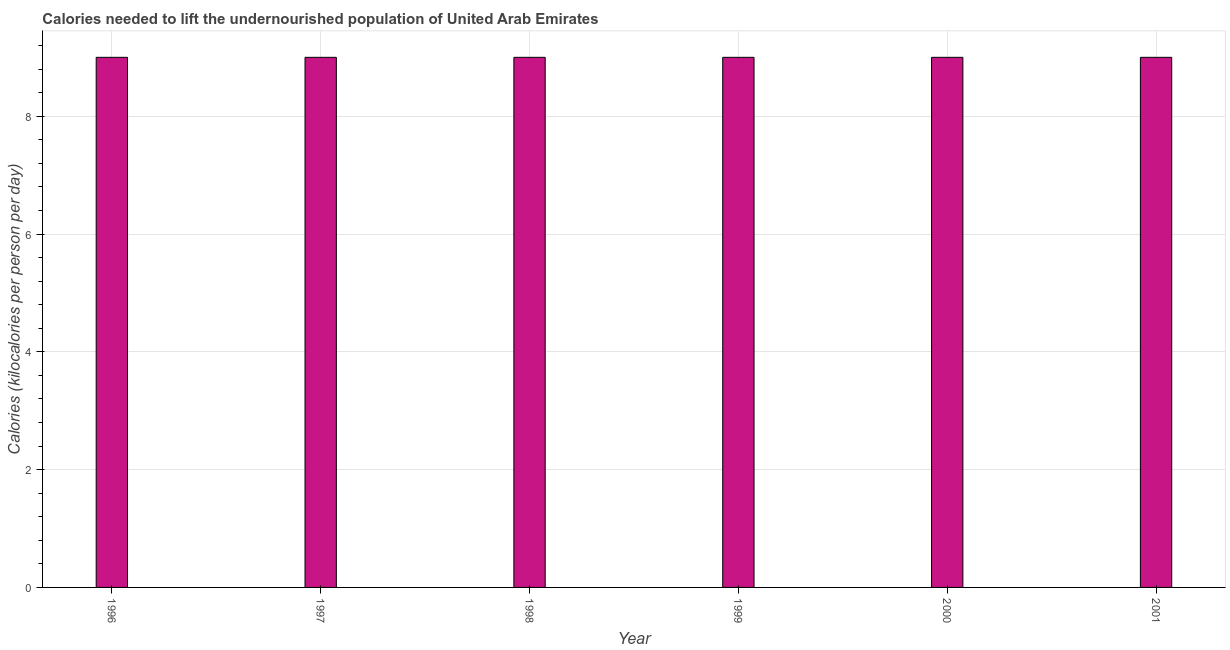What is the title of the graph?
Your answer should be very brief. Calories needed to lift the undernourished population of United Arab Emirates. What is the label or title of the X-axis?
Your response must be concise. Year. What is the label or title of the Y-axis?
Give a very brief answer. Calories (kilocalories per person per day). What is the sum of the depth of food deficit?
Offer a terse response. 54. What is the difference between the depth of food deficit in 1996 and 1998?
Ensure brevity in your answer.  0. What is the ratio of the depth of food deficit in 1998 to that in 1999?
Provide a succinct answer. 1. Is the difference between the depth of food deficit in 1997 and 2001 greater than the difference between any two years?
Make the answer very short. Yes. Is the sum of the depth of food deficit in 1996 and 1999 greater than the maximum depth of food deficit across all years?
Keep it short and to the point. Yes. In how many years, is the depth of food deficit greater than the average depth of food deficit taken over all years?
Offer a terse response. 0. How many bars are there?
Ensure brevity in your answer.  6. How many years are there in the graph?
Keep it short and to the point. 6. What is the difference between two consecutive major ticks on the Y-axis?
Offer a terse response. 2. Are the values on the major ticks of Y-axis written in scientific E-notation?
Your response must be concise. No. What is the Calories (kilocalories per person per day) in 1996?
Offer a terse response. 9. What is the Calories (kilocalories per person per day) of 2000?
Offer a terse response. 9. What is the difference between the Calories (kilocalories per person per day) in 1996 and 1997?
Your answer should be very brief. 0. What is the difference between the Calories (kilocalories per person per day) in 1996 and 1999?
Your answer should be very brief. 0. What is the difference between the Calories (kilocalories per person per day) in 1996 and 2000?
Your response must be concise. 0. What is the difference between the Calories (kilocalories per person per day) in 1997 and 1998?
Offer a very short reply. 0. What is the difference between the Calories (kilocalories per person per day) in 1997 and 1999?
Provide a succinct answer. 0. What is the difference between the Calories (kilocalories per person per day) in 1997 and 2001?
Keep it short and to the point. 0. What is the difference between the Calories (kilocalories per person per day) in 1998 and 1999?
Keep it short and to the point. 0. What is the difference between the Calories (kilocalories per person per day) in 1998 and 2001?
Your response must be concise. 0. What is the ratio of the Calories (kilocalories per person per day) in 1996 to that in 1997?
Your answer should be very brief. 1. What is the ratio of the Calories (kilocalories per person per day) in 1996 to that in 1999?
Your answer should be very brief. 1. What is the ratio of the Calories (kilocalories per person per day) in 1997 to that in 1998?
Ensure brevity in your answer.  1. What is the ratio of the Calories (kilocalories per person per day) in 1997 to that in 2001?
Provide a short and direct response. 1. What is the ratio of the Calories (kilocalories per person per day) in 1998 to that in 2001?
Ensure brevity in your answer.  1. What is the ratio of the Calories (kilocalories per person per day) in 1999 to that in 2000?
Provide a succinct answer. 1. What is the ratio of the Calories (kilocalories per person per day) in 1999 to that in 2001?
Your answer should be compact. 1. 